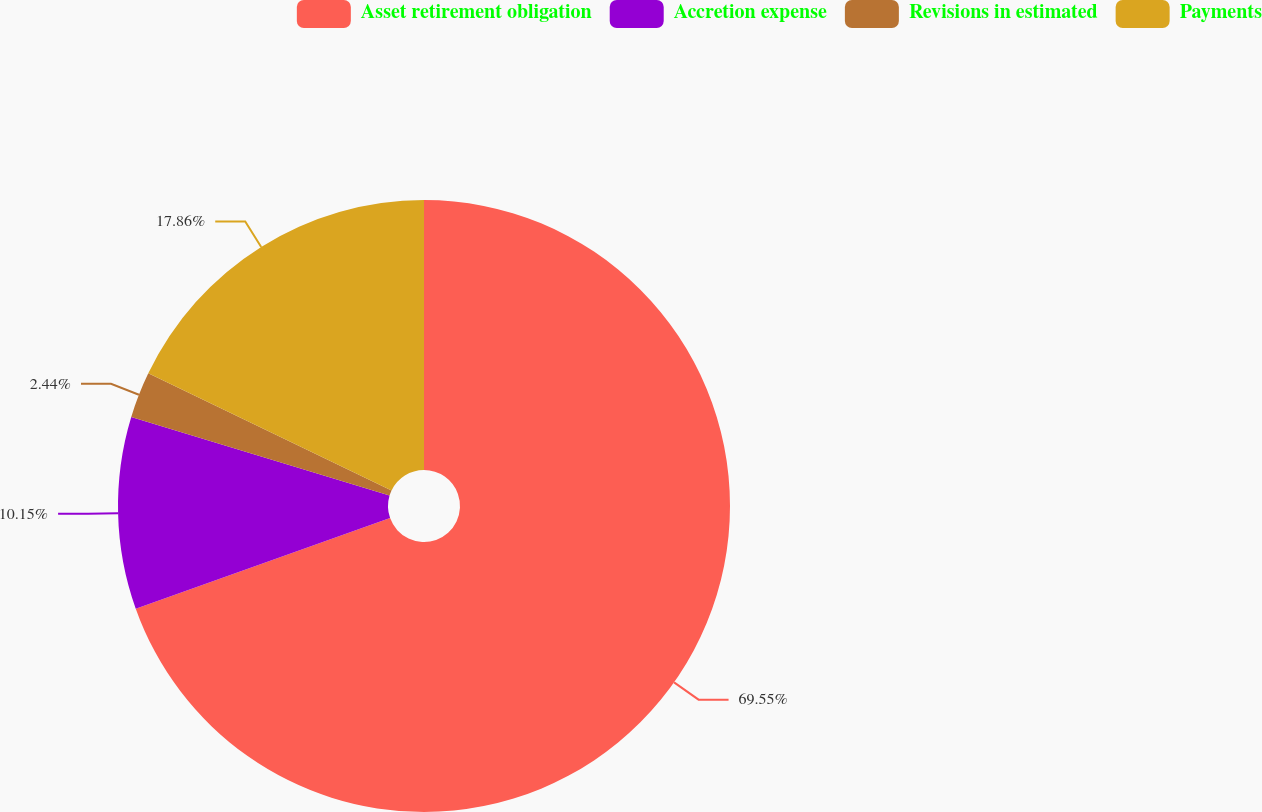<chart> <loc_0><loc_0><loc_500><loc_500><pie_chart><fcel>Asset retirement obligation<fcel>Accretion expense<fcel>Revisions in estimated<fcel>Payments<nl><fcel>69.56%<fcel>10.15%<fcel>2.44%<fcel>17.86%<nl></chart> 